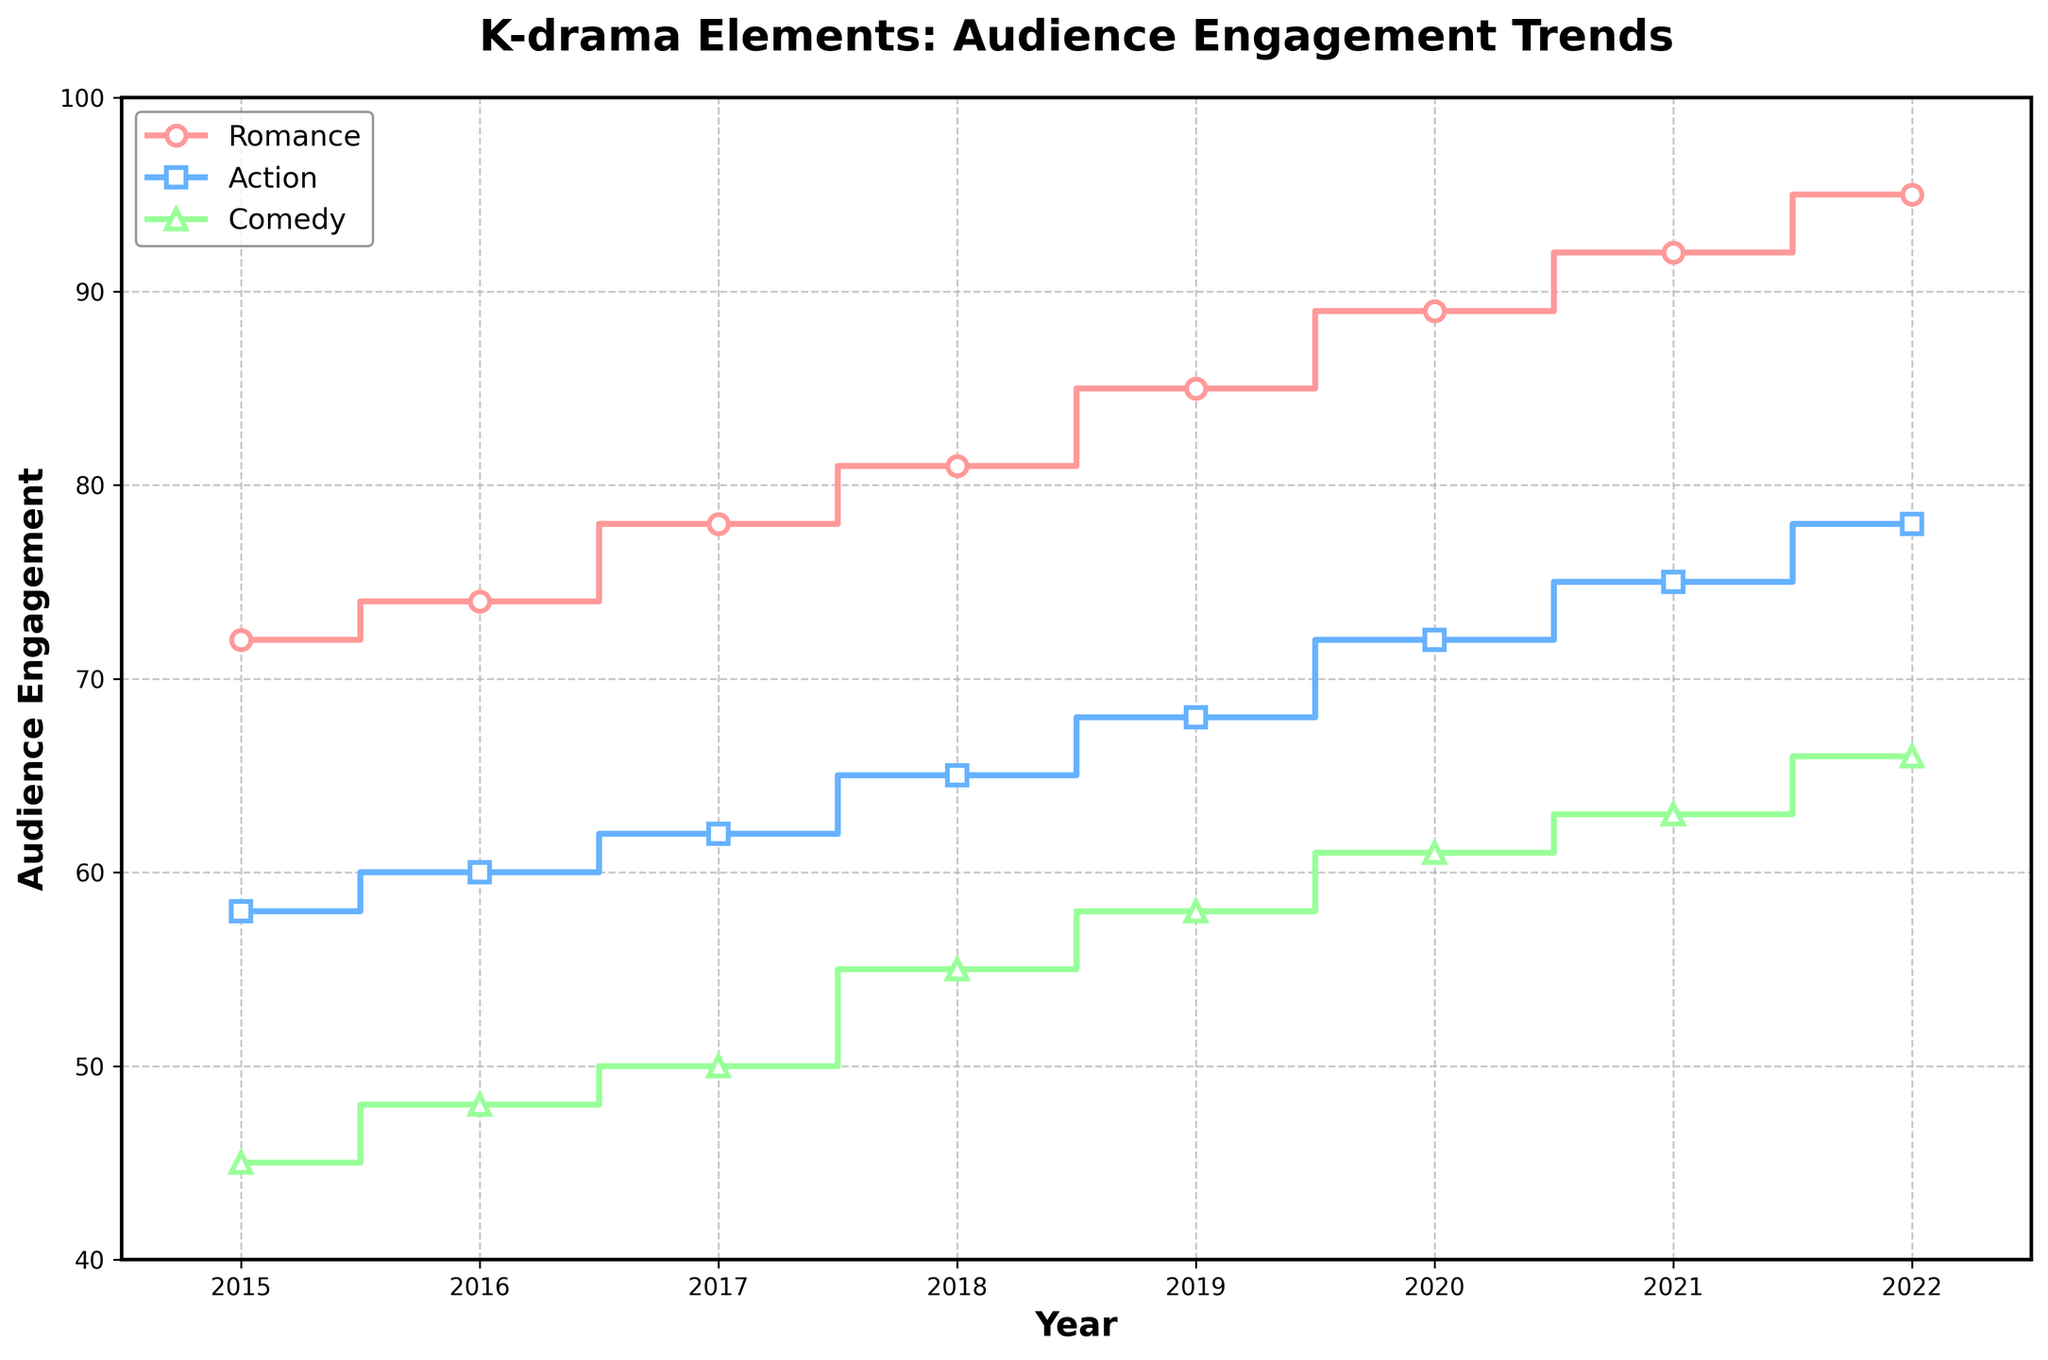what's the title of the figure? The title is found at the top of the figure in bold, indicating what the plot is about.
Answer: K-drama Elements: Audience Engagement Trends How many elements are charted in the figure? The legend shows that there are three differently colored lines representing different elements.
Answer: 3 Which K-drama element had the highest audience engagement in 2022? By looking at the data points for 2022, the line representing Romance reaches the highest engagement value.
Answer: Romance What is the range of audience engagement for Comedy between 2015 and 2022? The lowest engagement for Comedy is in 2015 at 45, and the highest is in 2022 at 66.
Answer: 45 to 66 In which year did the Action genre first surpass 70 in audience engagement? The step plot shows that the Action genre first reaches above 70 in the year 2020.
Answer: 2020 By how much did Romance's audience engagement increase from 2015 to 2022? Engagement for Romance in 2015 is 72, and in 2022 it is 95. The increase is 95 - 72.
Answer: 23 Which K-drama element consistently shows an upward trend in audience engagement from 2015 to 2022? The lines for all three elements (Romance, Action, Comedy) steadily increase, indicating an upward trend.
Answer: Romance, Action, and Comedy What is the average audience engagement for Action across all the years? Summing the values for Action (58+60+62+65+68+72+75+78) and then dividing by the number of years (8) gives the average.
Answer: 67 Compare the engagement levels between Comedy and Action in 2019, and which had higher engagement? For 2019, Comedy had 58 and Action had 68. By comparing the two values, Action had the higher engagement.
Answer: Action What year had the smallest difference in audience engagement between Romance and Comedy? Calculate the difference for each year: 2015 (27), 2016 (26), 2017 (28), 2018 (26), 2019 (27), 2020 (28), 2021 (29), 2022 (29). The smallest differences are in 2016 and 2018.
Answer: 2016 and 2018 